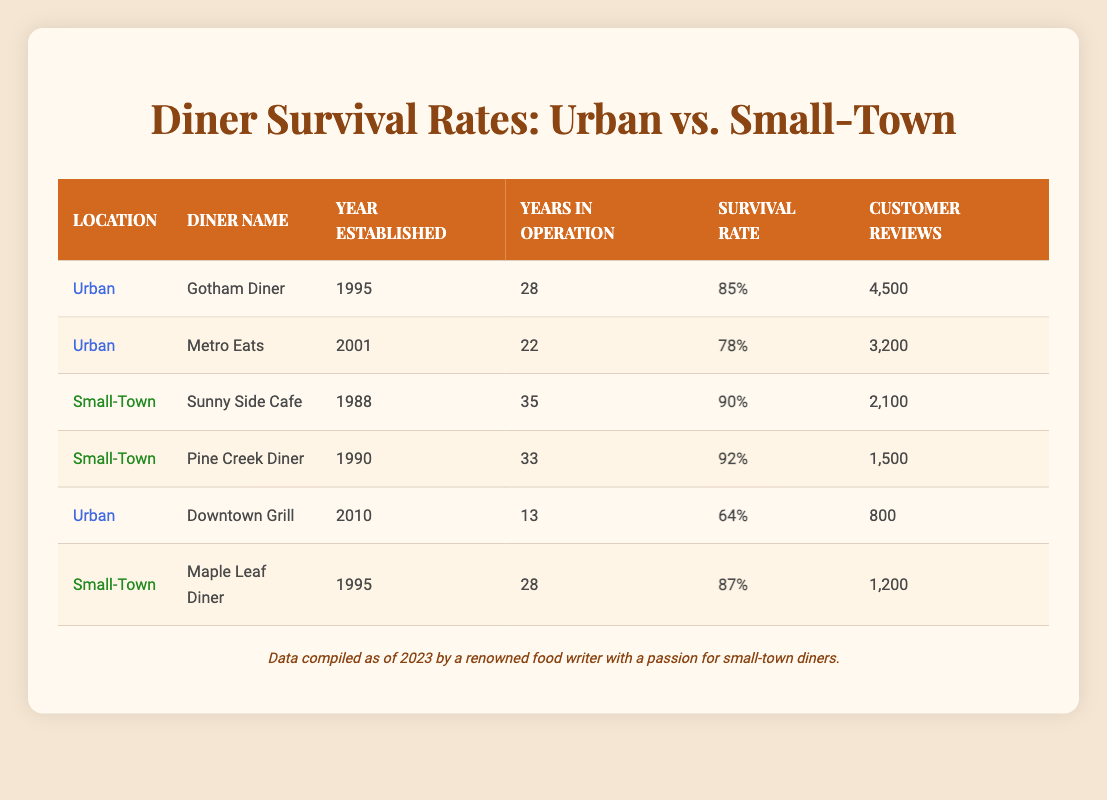What is the survival rate of Pine Creek Diner? The survival rate for Pine Creek Diner can be found in the table under the survival rate column corresponding to the row for Pine Creek Diner, which shows a survival rate of 92%.
Answer: 92% How many customer reviews does Gotham Diner have? You can find the number of customer reviews for Gotham Diner in the 'Customer Reviews' column in the row corresponding to Gotham Diner, which indicates 4,500 reviews.
Answer: 4,500 Which diner has the highest survival rate? To determine the diner with the highest survival rate, compare the survival rates listed in the table. Pine Creek Diner has the highest at 92%.
Answer: Pine Creek Diner What is the average survival rate for urban diners? The urban diners listed are Gotham Diner, Metro Eats, and Downtown Grill. Their survival rates are 85%, 78%, and 64%. We sum these: (85 + 78 + 64) = 227, and then divide by the number of urban diners, which is 3: 227 / 3 = 75.67%.
Answer: 75.67% Is the survival rate of Sunny Side Cafe higher than that of Downtown Grill? The survival rate for Sunny Side Cafe is 90% and for Downtown Grill is 64%. Since 90% is greater than 64%, the statement is true.
Answer: Yes How many years has the Maple Leaf Diner been in operation? The years in operation for Maple Leaf Diner is listed directly in the table, which states that it has been in operation for 28 years.
Answer: 28 Do urban diners generally have a higher survival rate than small-town diners based on this data? Comparing the average survival rates, urban diners have an average of 75.67%, while small-town diners (Sunny Side Cafe, Pine Creek Diner, and Maple Leaf Diner) average at (90 + 92 + 87) = 269 / 3 = 89.67%. Since 75.67% is less than 89.67%, urban diners do not generally have a higher survival rate.
Answer: No What is the difference in survival rates between Metro Eats and Maple Leaf Diner? From the table, the survival rate of Metro Eats is 78% while that of Maple Leaf Diner is 87%. The difference is calculated as 87 - 78 = 9%.
Answer: 9% 